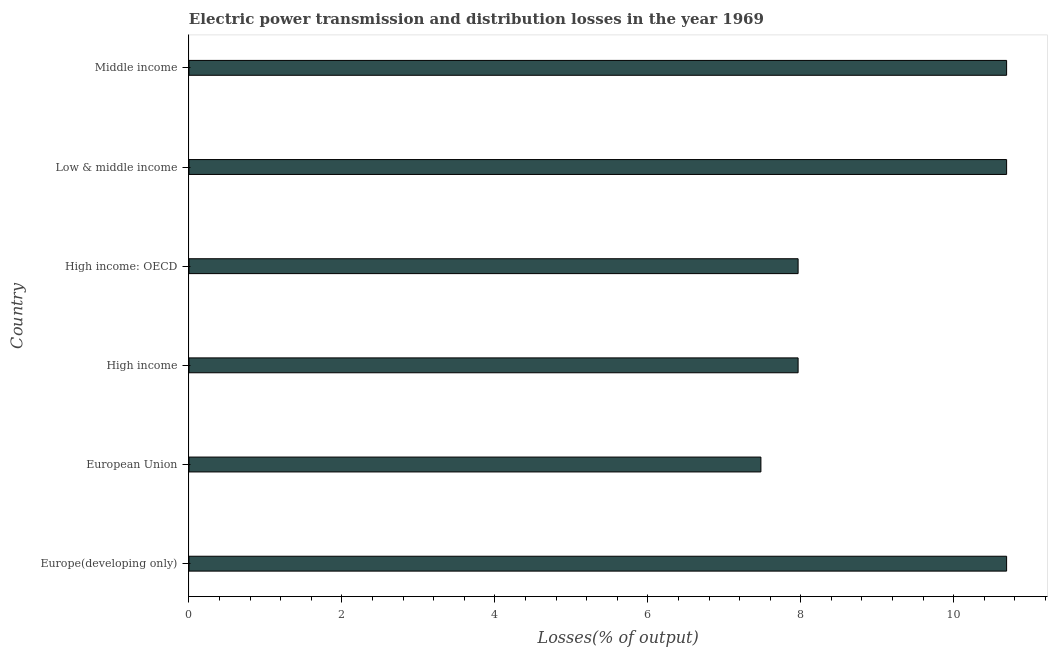What is the title of the graph?
Keep it short and to the point. Electric power transmission and distribution losses in the year 1969. What is the label or title of the X-axis?
Offer a very short reply. Losses(% of output). What is the electric power transmission and distribution losses in Europe(developing only)?
Your answer should be compact. 10.69. Across all countries, what is the maximum electric power transmission and distribution losses?
Make the answer very short. 10.69. Across all countries, what is the minimum electric power transmission and distribution losses?
Your response must be concise. 7.48. In which country was the electric power transmission and distribution losses maximum?
Give a very brief answer. Europe(developing only). In which country was the electric power transmission and distribution losses minimum?
Provide a short and direct response. European Union. What is the sum of the electric power transmission and distribution losses?
Offer a very short reply. 55.48. What is the difference between the electric power transmission and distribution losses in European Union and Middle income?
Make the answer very short. -3.21. What is the average electric power transmission and distribution losses per country?
Provide a short and direct response. 9.25. What is the median electric power transmission and distribution losses?
Make the answer very short. 9.33. What is the ratio of the electric power transmission and distribution losses in Europe(developing only) to that in European Union?
Offer a terse response. 1.43. What is the difference between the highest and the second highest electric power transmission and distribution losses?
Offer a terse response. 0. What is the difference between the highest and the lowest electric power transmission and distribution losses?
Your answer should be very brief. 3.21. How many bars are there?
Make the answer very short. 6. Are the values on the major ticks of X-axis written in scientific E-notation?
Give a very brief answer. No. What is the Losses(% of output) in Europe(developing only)?
Your answer should be compact. 10.69. What is the Losses(% of output) in European Union?
Your response must be concise. 7.48. What is the Losses(% of output) in High income?
Offer a very short reply. 7.97. What is the Losses(% of output) in High income: OECD?
Keep it short and to the point. 7.97. What is the Losses(% of output) of Low & middle income?
Your answer should be very brief. 10.69. What is the Losses(% of output) of Middle income?
Provide a short and direct response. 10.69. What is the difference between the Losses(% of output) in Europe(developing only) and European Union?
Provide a short and direct response. 3.21. What is the difference between the Losses(% of output) in Europe(developing only) and High income?
Ensure brevity in your answer.  2.73. What is the difference between the Losses(% of output) in Europe(developing only) and High income: OECD?
Your answer should be very brief. 2.73. What is the difference between the Losses(% of output) in European Union and High income?
Give a very brief answer. -0.49. What is the difference between the Losses(% of output) in European Union and High income: OECD?
Make the answer very short. -0.49. What is the difference between the Losses(% of output) in European Union and Low & middle income?
Offer a terse response. -3.21. What is the difference between the Losses(% of output) in European Union and Middle income?
Provide a short and direct response. -3.21. What is the difference between the Losses(% of output) in High income and High income: OECD?
Offer a very short reply. 0. What is the difference between the Losses(% of output) in High income and Low & middle income?
Make the answer very short. -2.73. What is the difference between the Losses(% of output) in High income and Middle income?
Your response must be concise. -2.73. What is the difference between the Losses(% of output) in High income: OECD and Low & middle income?
Offer a very short reply. -2.73. What is the difference between the Losses(% of output) in High income: OECD and Middle income?
Provide a short and direct response. -2.73. What is the difference between the Losses(% of output) in Low & middle income and Middle income?
Make the answer very short. 0. What is the ratio of the Losses(% of output) in Europe(developing only) to that in European Union?
Your answer should be compact. 1.43. What is the ratio of the Losses(% of output) in Europe(developing only) to that in High income?
Keep it short and to the point. 1.34. What is the ratio of the Losses(% of output) in Europe(developing only) to that in High income: OECD?
Give a very brief answer. 1.34. What is the ratio of the Losses(% of output) in Europe(developing only) to that in Middle income?
Make the answer very short. 1. What is the ratio of the Losses(% of output) in European Union to that in High income?
Your response must be concise. 0.94. What is the ratio of the Losses(% of output) in European Union to that in High income: OECD?
Provide a succinct answer. 0.94. What is the ratio of the Losses(% of output) in European Union to that in Low & middle income?
Offer a terse response. 0.7. What is the ratio of the Losses(% of output) in European Union to that in Middle income?
Your answer should be very brief. 0.7. What is the ratio of the Losses(% of output) in High income to that in High income: OECD?
Provide a short and direct response. 1. What is the ratio of the Losses(% of output) in High income to that in Low & middle income?
Your answer should be very brief. 0.74. What is the ratio of the Losses(% of output) in High income to that in Middle income?
Give a very brief answer. 0.74. What is the ratio of the Losses(% of output) in High income: OECD to that in Low & middle income?
Keep it short and to the point. 0.74. What is the ratio of the Losses(% of output) in High income: OECD to that in Middle income?
Your answer should be very brief. 0.74. What is the ratio of the Losses(% of output) in Low & middle income to that in Middle income?
Your response must be concise. 1. 